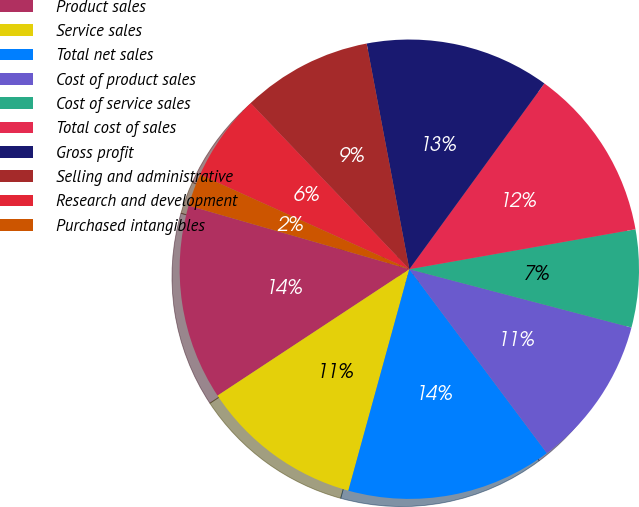Convert chart. <chart><loc_0><loc_0><loc_500><loc_500><pie_chart><fcel>Product sales<fcel>Service sales<fcel>Total net sales<fcel>Cost of product sales<fcel>Cost of service sales<fcel>Total cost of sales<fcel>Gross profit<fcel>Selling and administrative<fcel>Research and development<fcel>Purchased intangibles<nl><fcel>13.74%<fcel>11.45%<fcel>14.5%<fcel>10.69%<fcel>6.87%<fcel>12.21%<fcel>12.98%<fcel>9.16%<fcel>6.11%<fcel>2.29%<nl></chart> 